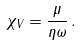Convert formula to latex. <formula><loc_0><loc_0><loc_500><loc_500>\chi _ { V } = \frac { \mu } { \eta \omega } \, .</formula> 